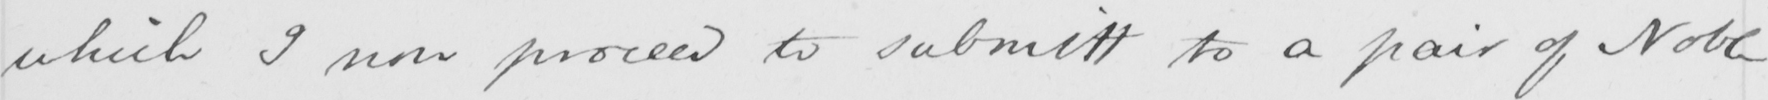Transcribe the text shown in this historical manuscript line. which I now proceed to submitt to a pair of Noble 